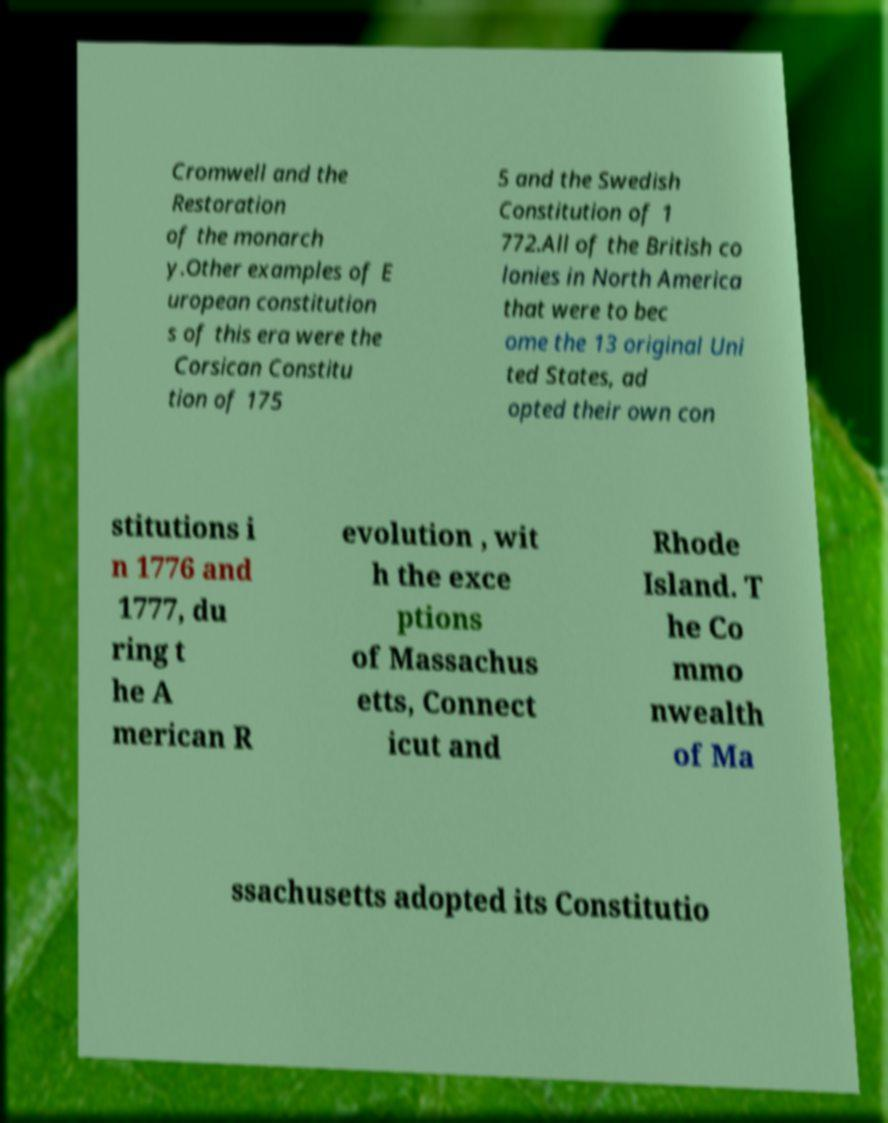Please identify and transcribe the text found in this image. Cromwell and the Restoration of the monarch y.Other examples of E uropean constitution s of this era were the Corsican Constitu tion of 175 5 and the Swedish Constitution of 1 772.All of the British co lonies in North America that were to bec ome the 13 original Uni ted States, ad opted their own con stitutions i n 1776 and 1777, du ring t he A merican R evolution , wit h the exce ptions of Massachus etts, Connect icut and Rhode Island. T he Co mmo nwealth of Ma ssachusetts adopted its Constitutio 